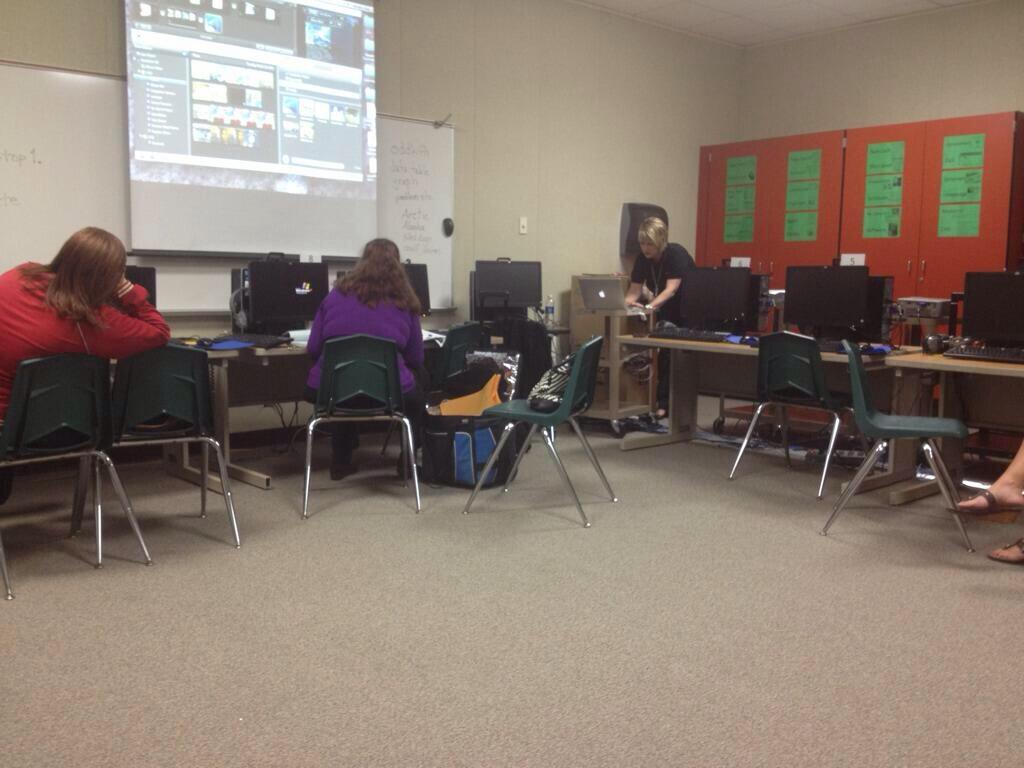Describe this image in one or two sentences. This image show the hall in which there are three women who are sitting and working. There are so many desktops which are kept on table. At the left corner there is a woman sitting and looking at the board. There is a bag in the middle of the image. There is a screen in front of woman who is sitting in the middle. There is a cupboard to the right corner. There is a black board attached to the wall. 